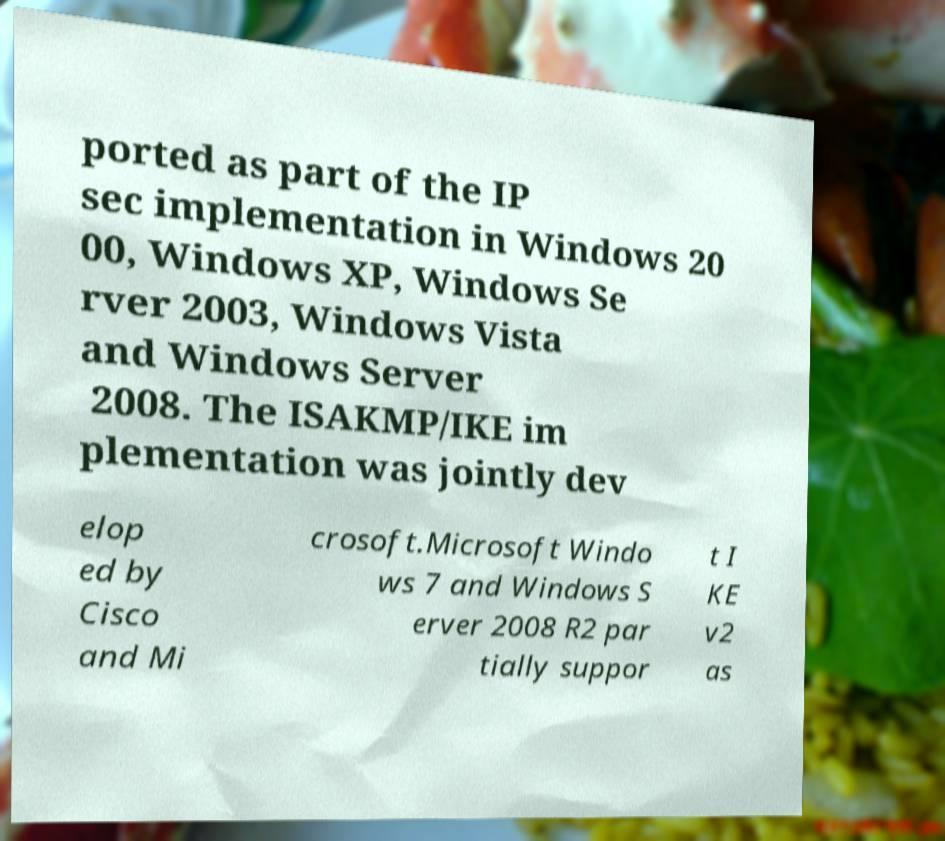I need the written content from this picture converted into text. Can you do that? ported as part of the IP sec implementation in Windows 20 00, Windows XP, Windows Se rver 2003, Windows Vista and Windows Server 2008. The ISAKMP/IKE im plementation was jointly dev elop ed by Cisco and Mi crosoft.Microsoft Windo ws 7 and Windows S erver 2008 R2 par tially suppor t I KE v2 as 